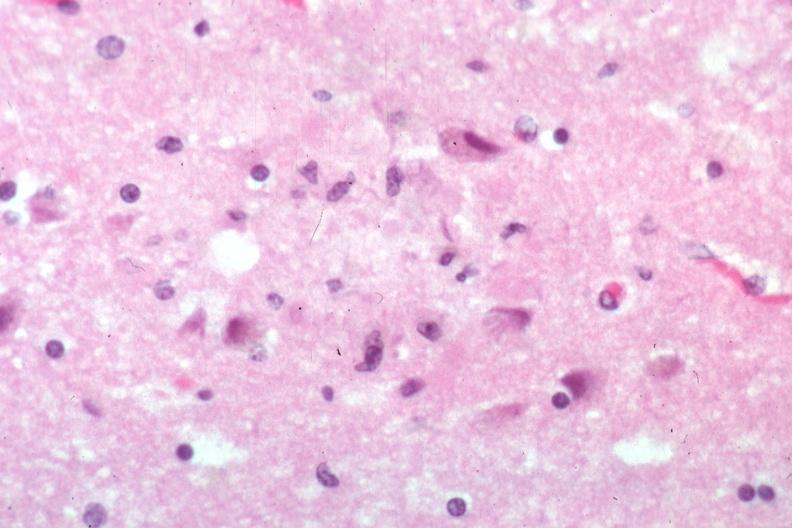s senile plaque present?
Answer the question using a single word or phrase. Yes 